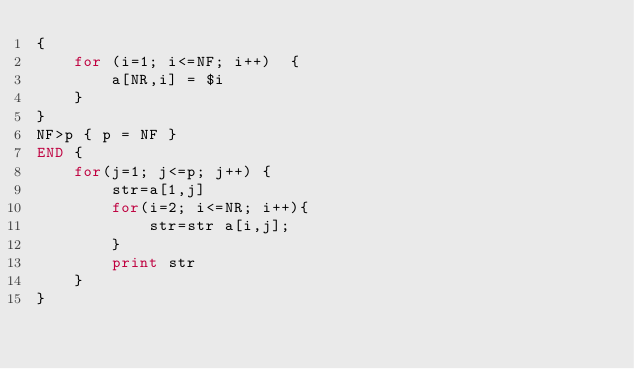Convert code to text. <code><loc_0><loc_0><loc_500><loc_500><_Awk_>{ 
    for (i=1; i<=NF; i++)  {
        a[NR,i] = $i
    }
}
NF>p { p = NF }
END {    
    for(j=1; j<=p; j++) {
        str=a[1,j]
        for(i=2; i<=NR; i++){
            str=str a[i,j];
        }
        print str
    }
}
</code> 